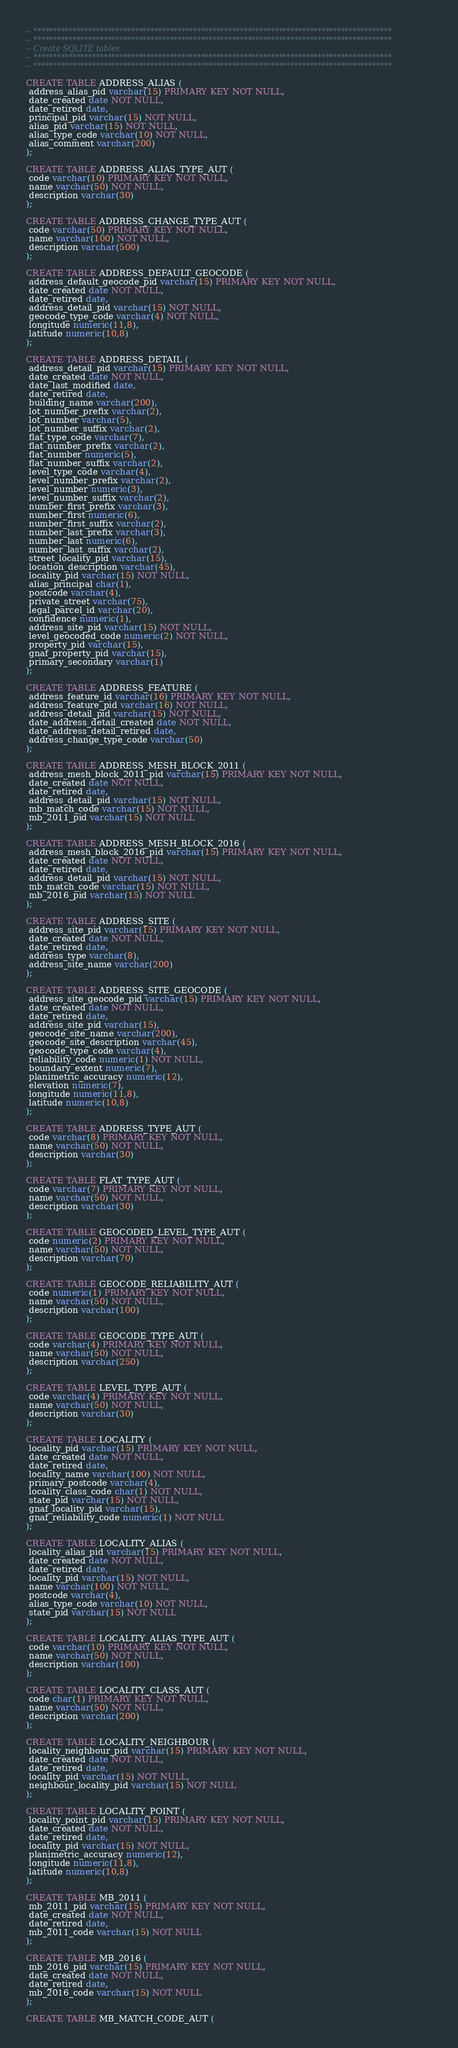<code> <loc_0><loc_0><loc_500><loc_500><_SQL_>-- ********************************************************************************************
-- ********************************************************************************************
-- Create SQLITE tables 
-- ********************************************************************************************
-- ********************************************************************************************

CREATE TABLE ADDRESS_ALIAS (
 address_alias_pid varchar(15) PRIMARY KEY NOT NULL,
 date_created date NOT NULL,
 date_retired date,
 principal_pid varchar(15) NOT NULL,
 alias_pid varchar(15) NOT NULL,
 alias_type_code varchar(10) NOT NULL,
 alias_comment varchar(200)
);

CREATE TABLE ADDRESS_ALIAS_TYPE_AUT (
 code varchar(10) PRIMARY KEY NOT NULL,
 name varchar(50) NOT NULL,
 description varchar(30)
);

CREATE TABLE ADDRESS_CHANGE_TYPE_AUT (
 code varchar(50) PRIMARY KEY NOT NULL,
 name varchar(100) NOT NULL,
 description varchar(500)
);

CREATE TABLE ADDRESS_DEFAULT_GEOCODE (
 address_default_geocode_pid varchar(15) PRIMARY KEY NOT NULL,
 date_created date NOT NULL,
 date_retired date,
 address_detail_pid varchar(15) NOT NULL,
 geocode_type_code varchar(4) NOT NULL,
 longitude numeric(11,8),
 latitude numeric(10,8)
);

CREATE TABLE ADDRESS_DETAIL (
 address_detail_pid varchar(15) PRIMARY KEY NOT NULL,
 date_created date NOT NULL,
 date_last_modified date,
 date_retired date,
 building_name varchar(200),
 lot_number_prefix varchar(2),
 lot_number varchar(5),
 lot_number_suffix varchar(2),
 flat_type_code varchar(7),
 flat_number_prefix varchar(2),
 flat_number numeric(5),
 flat_number_suffix varchar(2),
 level_type_code varchar(4),
 level_number_prefix varchar(2),
 level_number numeric(3),
 level_number_suffix varchar(2),
 number_first_prefix varchar(3),
 number_first numeric(6),
 number_first_suffix varchar(2),
 number_last_prefix varchar(3),
 number_last numeric(6),
 number_last_suffix varchar(2),
 street_locality_pid varchar(15),
 location_description varchar(45),
 locality_pid varchar(15) NOT NULL,
 alias_principal char(1),
 postcode varchar(4),
 private_street varchar(75),
 legal_parcel_id varchar(20),
 confidence numeric(1),
 address_site_pid varchar(15) NOT NULL,
 level_geocoded_code numeric(2) NOT NULL,
 property_pid varchar(15),
 gnaf_property_pid varchar(15),
 primary_secondary varchar(1)
);

CREATE TABLE ADDRESS_FEATURE (
 address_feature_id varchar(16) PRIMARY KEY NOT NULL,
 address_feature_pid varchar(16) NOT NULL,
 address_detail_pid varchar(15) NOT NULL,
 date_address_detail_created date NOT NULL,
 date_address_detail_retired date,
 address_change_type_code varchar(50)
);

CREATE TABLE ADDRESS_MESH_BLOCK_2011 (
 address_mesh_block_2011_pid varchar(15) PRIMARY KEY NOT NULL,
 date_created date NOT NULL,
 date_retired date,
 address_detail_pid varchar(15) NOT NULL,
 mb_match_code varchar(15) NOT NULL,
 mb_2011_pid varchar(15) NOT NULL
);

CREATE TABLE ADDRESS_MESH_BLOCK_2016 (
 address_mesh_block_2016_pid varchar(15) PRIMARY KEY NOT NULL,
 date_created date NOT NULL,
 date_retired date,
 address_detail_pid varchar(15) NOT NULL,
 mb_match_code varchar(15) NOT NULL,
 mb_2016_pid varchar(15) NOT NULL
);

CREATE TABLE ADDRESS_SITE (
 address_site_pid varchar(15) PRIMARY KEY NOT NULL,
 date_created date NOT NULL,
 date_retired date,
 address_type varchar(8),
 address_site_name varchar(200)
);

CREATE TABLE ADDRESS_SITE_GEOCODE (
 address_site_geocode_pid varchar(15) PRIMARY KEY NOT NULL,
 date_created date NOT NULL,
 date_retired date,
 address_site_pid varchar(15),
 geocode_site_name varchar(200),
 geocode_site_description varchar(45),
 geocode_type_code varchar(4),
 reliability_code numeric(1) NOT NULL,
 boundary_extent numeric(7),
 planimetric_accuracy numeric(12),
 elevation numeric(7),
 longitude numeric(11,8),
 latitude numeric(10,8)
);

CREATE TABLE ADDRESS_TYPE_AUT (
 code varchar(8) PRIMARY KEY NOT NULL,
 name varchar(50) NOT NULL,
 description varchar(30)
);

CREATE TABLE FLAT_TYPE_AUT (
 code varchar(7) PRIMARY KEY NOT NULL,
 name varchar(50) NOT NULL,
 description varchar(30)
);

CREATE TABLE GEOCODED_LEVEL_TYPE_AUT (
 code numeric(2) PRIMARY KEY NOT NULL,
 name varchar(50) NOT NULL,
 description varchar(70)
);

CREATE TABLE GEOCODE_RELIABILITY_AUT (
 code numeric(1) PRIMARY KEY NOT NULL,
 name varchar(50) NOT NULL,
 description varchar(100)
);

CREATE TABLE GEOCODE_TYPE_AUT (
 code varchar(4) PRIMARY KEY NOT NULL,
 name varchar(50) NOT NULL,
 description varchar(250)
);

CREATE TABLE LEVEL_TYPE_AUT (
 code varchar(4) PRIMARY KEY NOT NULL,
 name varchar(50) NOT NULL,
 description varchar(30)
);

CREATE TABLE LOCALITY (
 locality_pid varchar(15) PRIMARY KEY NOT NULL,
 date_created date NOT NULL,
 date_retired date,
 locality_name varchar(100) NOT NULL,
 primary_postcode varchar(4),
 locality_class_code char(1) NOT NULL,
 state_pid varchar(15) NOT NULL,
 gnaf_locality_pid varchar(15),
 gnaf_reliability_code numeric(1) NOT NULL
);

CREATE TABLE LOCALITY_ALIAS (
 locality_alias_pid varchar(15) PRIMARY KEY NOT NULL,
 date_created date NOT NULL,
 date_retired date,
 locality_pid varchar(15) NOT NULL,
 name varchar(100) NOT NULL,
 postcode varchar(4),
 alias_type_code varchar(10) NOT NULL,
 state_pid varchar(15) NOT NULL
);

CREATE TABLE LOCALITY_ALIAS_TYPE_AUT (
 code varchar(10) PRIMARY KEY NOT NULL,
 name varchar(50) NOT NULL,
 description varchar(100)
);

CREATE TABLE LOCALITY_CLASS_AUT (
 code char(1) PRIMARY KEY NOT NULL,
 name varchar(50) NOT NULL,
 description varchar(200)
);

CREATE TABLE LOCALITY_NEIGHBOUR (
 locality_neighbour_pid varchar(15) PRIMARY KEY NOT NULL,
 date_created date NOT NULL,
 date_retired date,
 locality_pid varchar(15) NOT NULL,
 neighbour_locality_pid varchar(15) NOT NULL
);

CREATE TABLE LOCALITY_POINT (
 locality_point_pid varchar(15) PRIMARY KEY NOT NULL,
 date_created date NOT NULL,
 date_retired date,
 locality_pid varchar(15) NOT NULL,
 planimetric_accuracy numeric(12),
 longitude numeric(11,8),
 latitude numeric(10,8)
);

CREATE TABLE MB_2011 (
 mb_2011_pid varchar(15) PRIMARY KEY NOT NULL,
 date_created date NOT NULL,
 date_retired date,
 mb_2011_code varchar(15) NOT NULL
);

CREATE TABLE MB_2016 (
 mb_2016_pid varchar(15) PRIMARY KEY NOT NULL,
 date_created date NOT NULL,
 date_retired date,
 mb_2016_code varchar(15) NOT NULL
);

CREATE TABLE MB_MATCH_CODE_AUT (</code> 